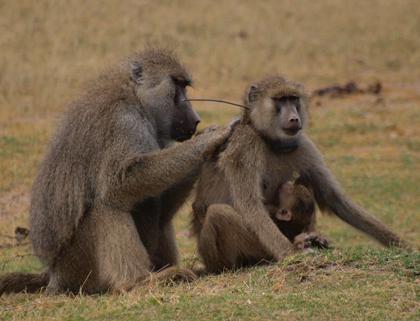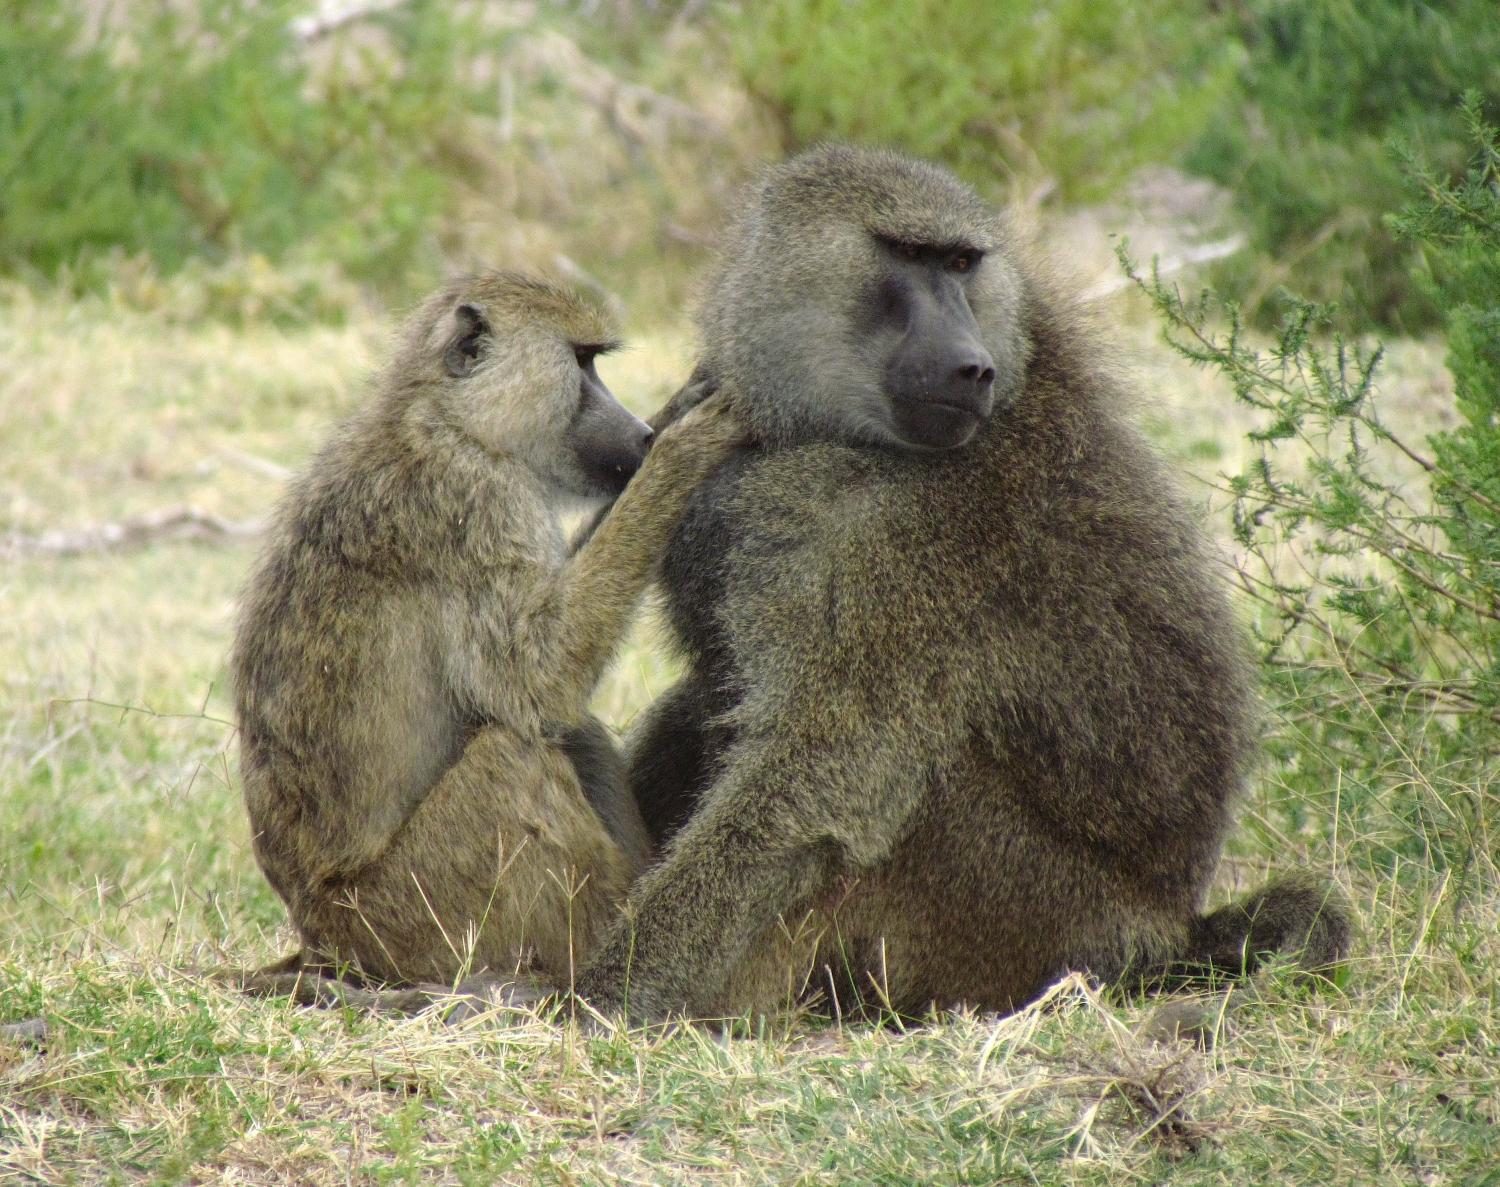The first image is the image on the left, the second image is the image on the right. Given the left and right images, does the statement "Both images contains an animal with both of its hands touching another animal in the head and neck area." hold true? Answer yes or no. Yes. 